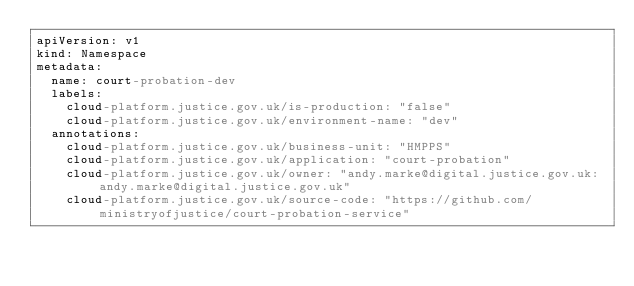<code> <loc_0><loc_0><loc_500><loc_500><_YAML_>apiVersion: v1
kind: Namespace
metadata:
  name: court-probation-dev
  labels:
    cloud-platform.justice.gov.uk/is-production: "false"
    cloud-platform.justice.gov.uk/environment-name: "dev"
  annotations:
    cloud-platform.justice.gov.uk/business-unit: "HMPPS"
    cloud-platform.justice.gov.uk/application: "court-probation"
    cloud-platform.justice.gov.uk/owner: "andy.marke@digital.justice.gov.uk: andy.marke@digital.justice.gov.uk"
    cloud-platform.justice.gov.uk/source-code: "https://github.com/ministryofjustice/court-probation-service"
</code> 